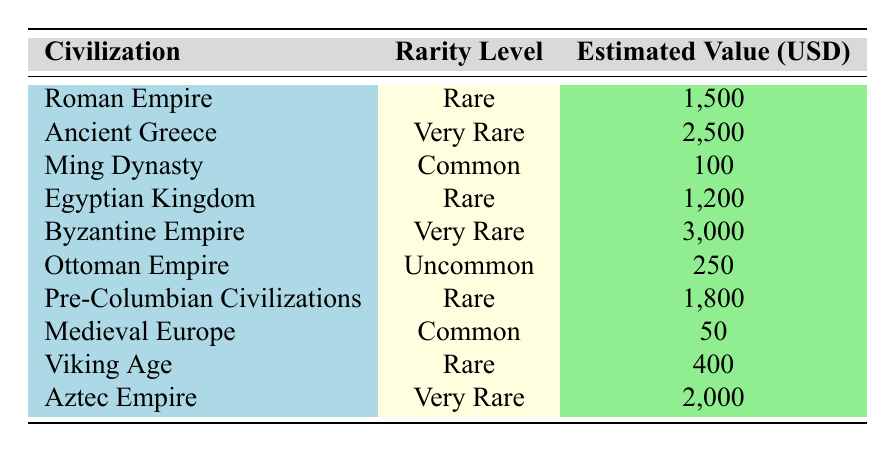What is the estimated value of the Denarius from the Roman Empire? The table indicates the estimated value for the Denarius is listed under the Roman Empire as 1,500 USD.
Answer: 1,500 Which civilization has the highest estimated coin value? According to the table, the Byzantine Empire's coin, which has a value of 3,000 USD, is the highest among all listed civilizations.
Answer: Byzantine Empire How many coins are categorized as Rare? The table shows four civilizations with coins that have a rarity level of Rare: Roman Empire, Egyptian Kingdom, Pre-Columbian Civilizations, and Viking Age. Therefore, there are 4 coins categorized as Rare.
Answer: 4 What is the total estimated value of all Very Rare coins? The Very Rare coins come from Ancient Greece (2,500 USD), Byzantine Empire (3,000 USD), and Aztec Empire (2,000 USD). Adding these gives: 2,500 + 3,000 + 2,000 = 7,500 USD, so the total estimated value is 7,500 USD.
Answer: 7,500 Is there a coin from the Ming Dynasty that is categorized as Rare? The table classifies the Kuan coin from the Ming Dynasty as Common, which means it is not Rare.
Answer: No What is the average estimated value of coins that are classified as Common? The Common coins are from the Ming Dynasty (100 USD) and Medieval Europe (50 USD). The sum of their values is 100 + 50 = 150 USD. Since there are two coins, the average value is 150 / 2 = 75 USD.
Answer: 75 Which civilization has a coin with the lowest estimated value? The table shows that the Medieval Europe Penny has the lowest estimated value at 50 USD, compared to other coin values.
Answer: Medieval Europe How many civilizations have coins with an Uncommon rarity level? The table indicates that only the Ottoman Empire has a coin with an Uncommon rarity level; therefore, there is just one civilization in this category.
Answer: 1 